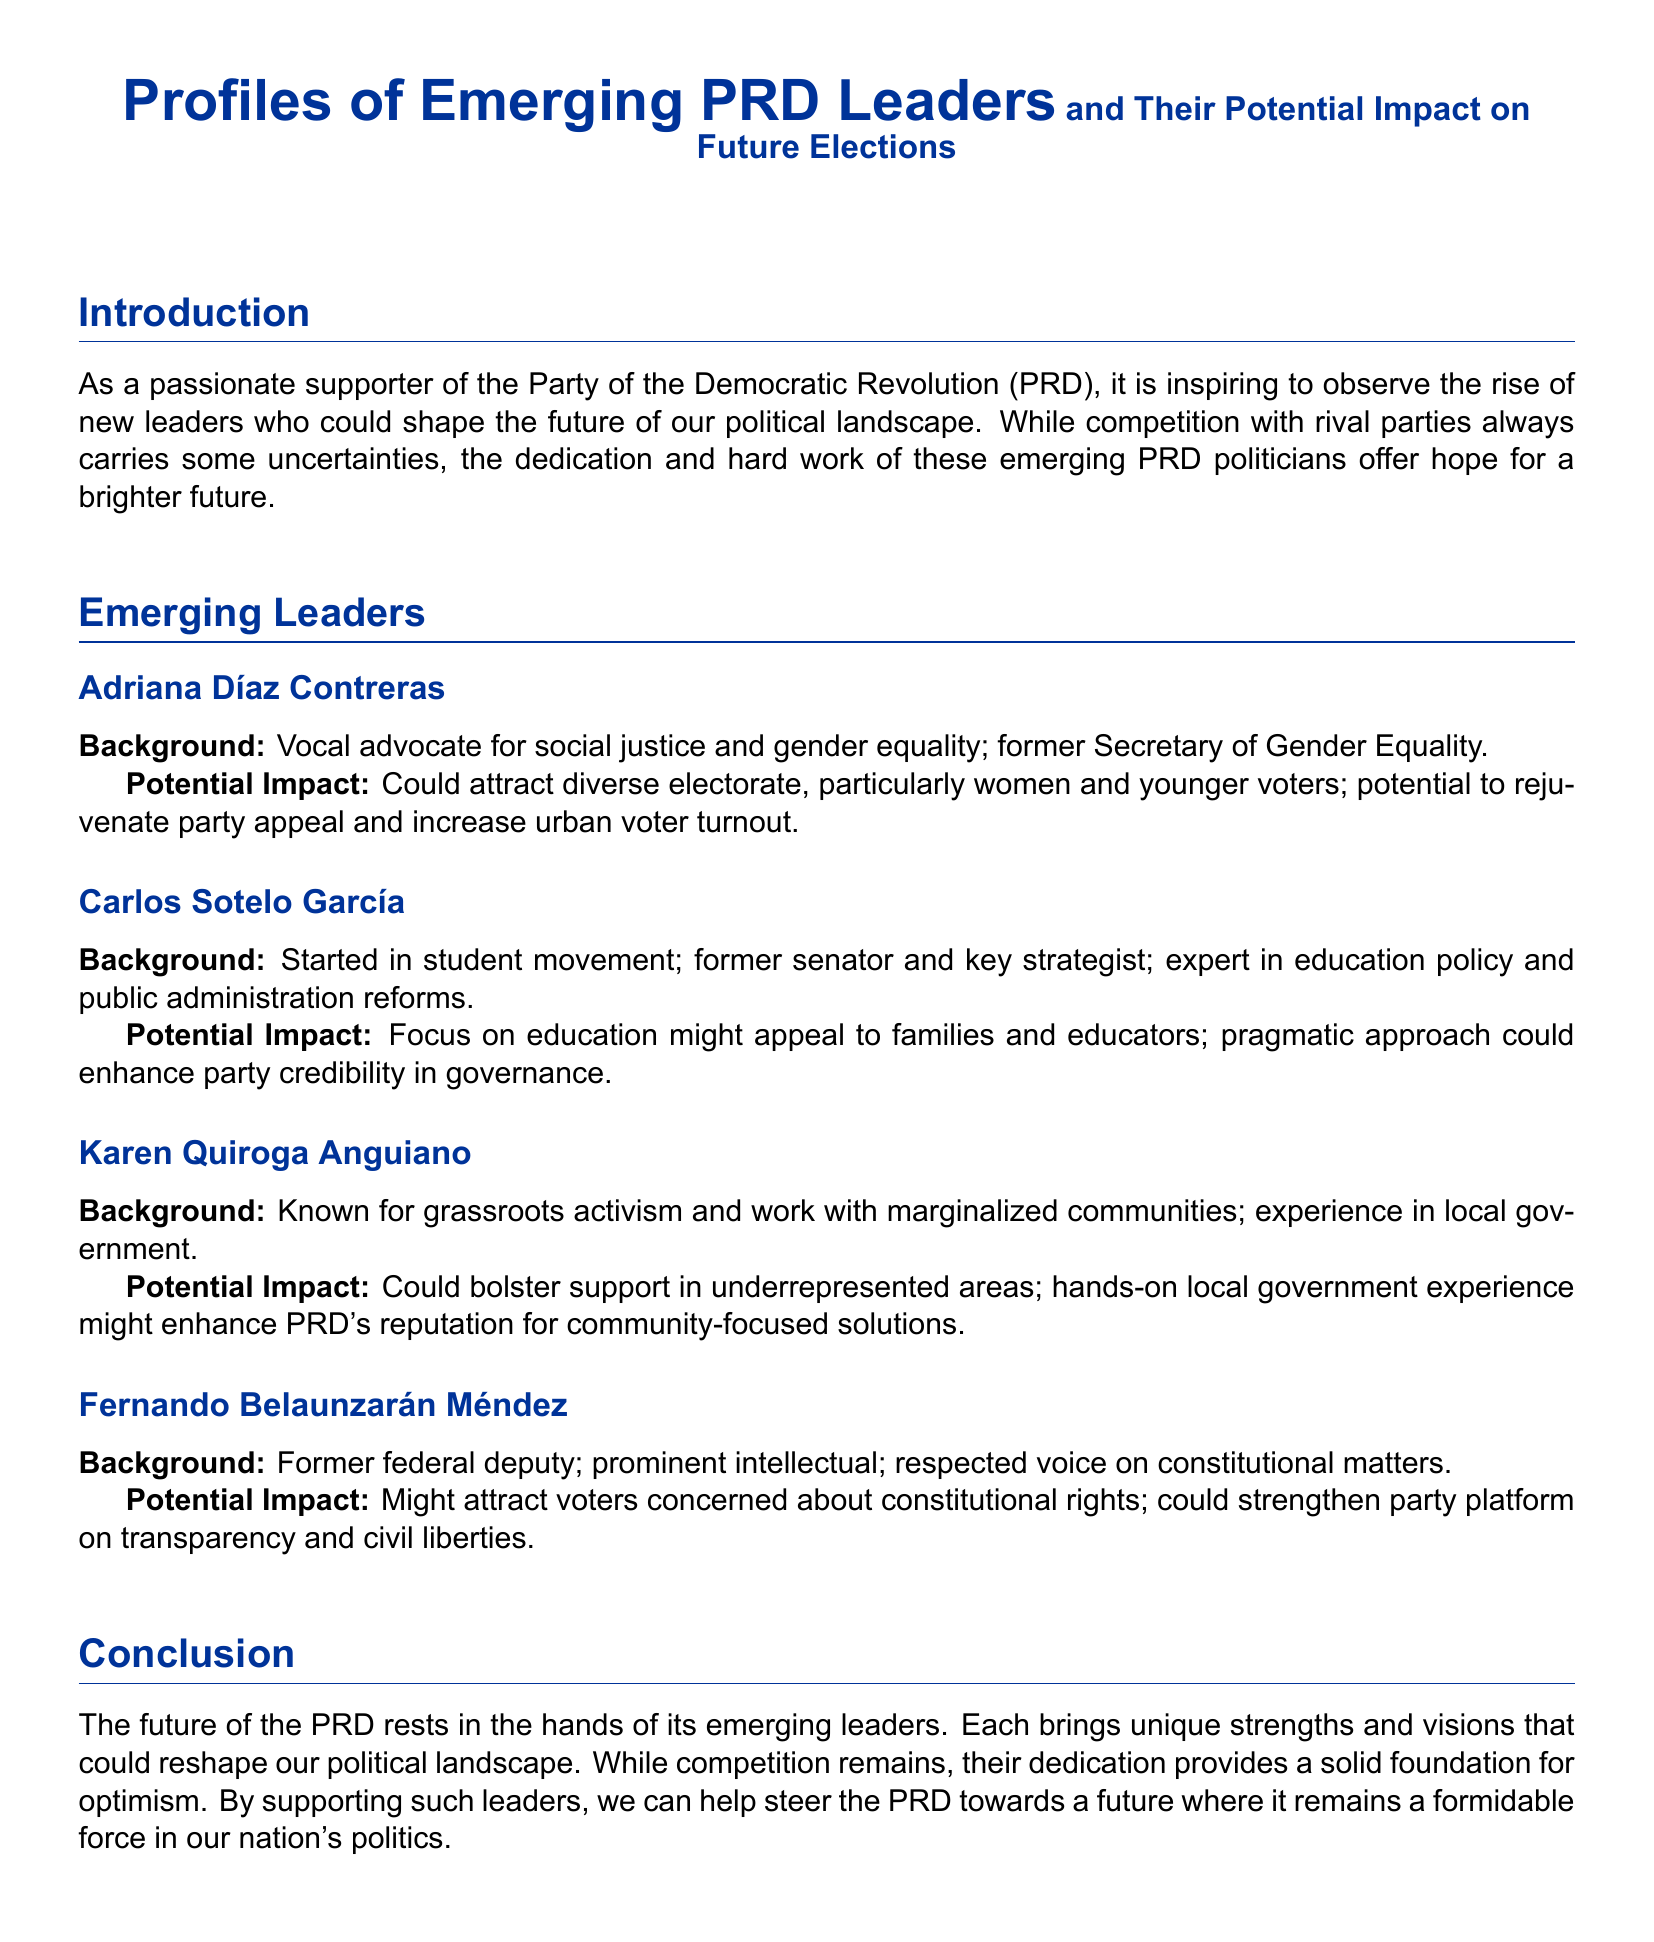What is Adriana Díaz Contreras known for? Adriana Díaz Contreras is a vocal advocate for social justice and gender equality.
Answer: social justice and gender equality What position did Carlos Sotelo García hold? Carlos Sotelo García is a former senator and key strategist.
Answer: former senator What kind of impact could Karen Quiroga Anguiano have? Karen Quiroga Anguiano could bolster support in underrepresented areas.
Answer: bolster support in underrepresented areas Who is a former federal deputy and respected voice on constitutional matters? Fernando Belaunzarán Méndez is a former federal deputy and respected voice on constitutional matters.
Answer: Fernando Belaunzarán Méndez What is the main focus of Carlos Sotelo García's potential appeal? Carlos Sotelo García's focus is on education policy.
Answer: education policy Which emergent leader is known for grassroots activism? Karen Quiroga Anguiano is known for grassroots activism.
Answer: Karen Quiroga Anguiano What is the role of emerging leaders in the PRD's future? Emerging leaders bring unique strengths and visions that could reshape the political landscape.
Answer: reshape the political landscape What could Fernando Belaunzarán Méndez attract voters concerned about? He might attract voters concerned about constitutional rights.
Answer: constitutional rights 